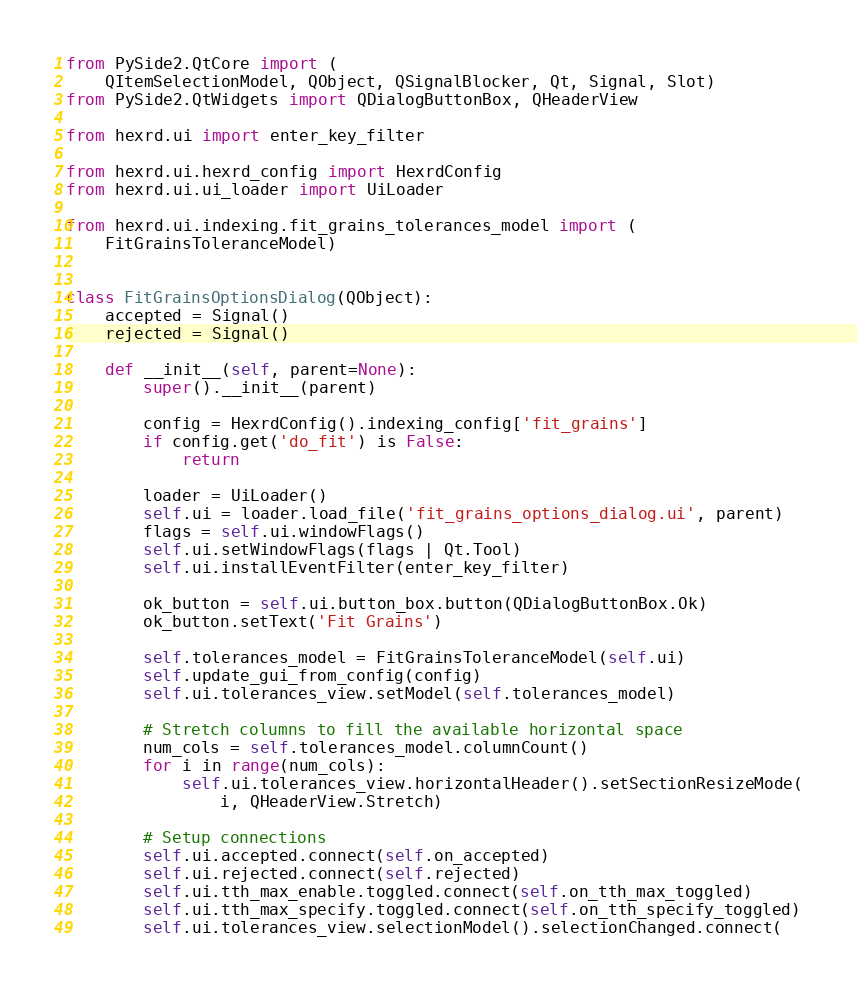<code> <loc_0><loc_0><loc_500><loc_500><_Python_>from PySide2.QtCore import (
    QItemSelectionModel, QObject, QSignalBlocker, Qt, Signal, Slot)
from PySide2.QtWidgets import QDialogButtonBox, QHeaderView

from hexrd.ui import enter_key_filter

from hexrd.ui.hexrd_config import HexrdConfig
from hexrd.ui.ui_loader import UiLoader

from hexrd.ui.indexing.fit_grains_tolerances_model import (
    FitGrainsToleranceModel)


class FitGrainsOptionsDialog(QObject):
    accepted = Signal()
    rejected = Signal()

    def __init__(self, parent=None):
        super().__init__(parent)

        config = HexrdConfig().indexing_config['fit_grains']
        if config.get('do_fit') is False:
            return

        loader = UiLoader()
        self.ui = loader.load_file('fit_grains_options_dialog.ui', parent)
        flags = self.ui.windowFlags()
        self.ui.setWindowFlags(flags | Qt.Tool)
        self.ui.installEventFilter(enter_key_filter)

        ok_button = self.ui.button_box.button(QDialogButtonBox.Ok)
        ok_button.setText('Fit Grains')

        self.tolerances_model = FitGrainsToleranceModel(self.ui)
        self.update_gui_from_config(config)
        self.ui.tolerances_view.setModel(self.tolerances_model)

        # Stretch columns to fill the available horizontal space
        num_cols = self.tolerances_model.columnCount()
        for i in range(num_cols):
            self.ui.tolerances_view.horizontalHeader().setSectionResizeMode(
                i, QHeaderView.Stretch)

        # Setup connections
        self.ui.accepted.connect(self.on_accepted)
        self.ui.rejected.connect(self.rejected)
        self.ui.tth_max_enable.toggled.connect(self.on_tth_max_toggled)
        self.ui.tth_max_specify.toggled.connect(self.on_tth_specify_toggled)
        self.ui.tolerances_view.selectionModel().selectionChanged.connect(</code> 